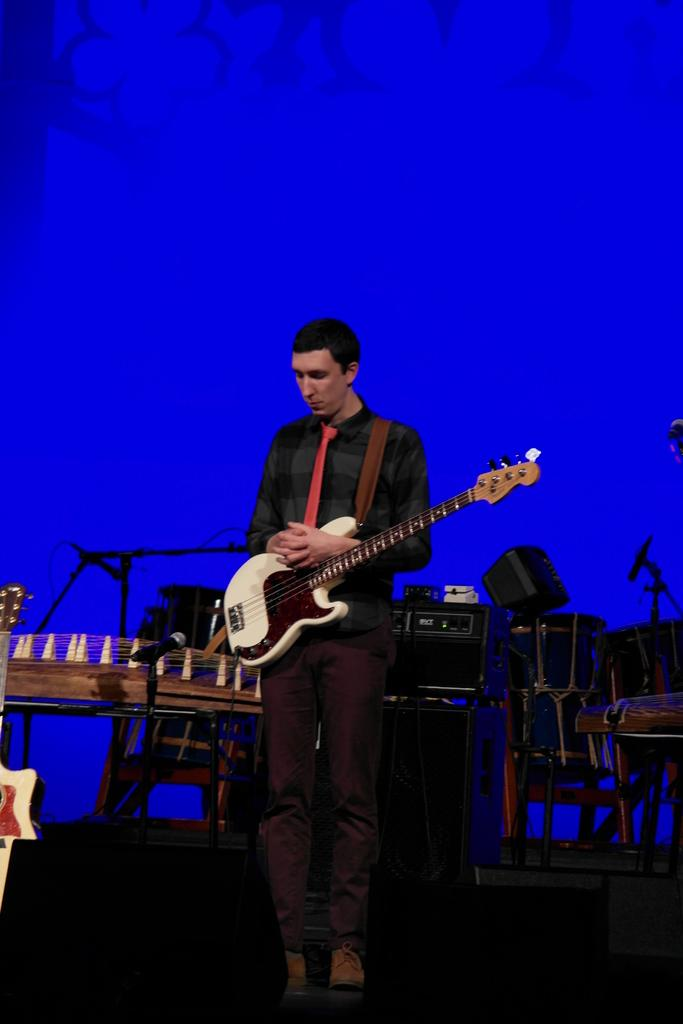What is the main subject of the image? There is a man in the image. What is the man doing in the image? The man is standing and holding a guitar. What can be seen in the background of the image? There is a music system, drums, and a blue color light in the background of the image. What type of argument is taking place between the man and the wall in the image? There is no wall present in the image, and therefore no argument can be observed. 